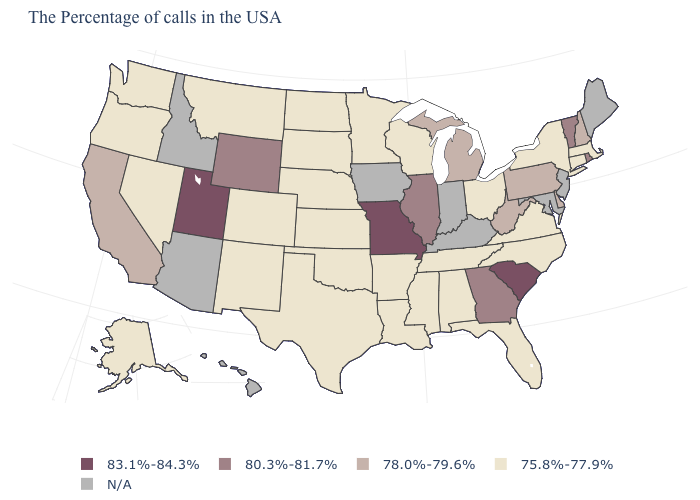Name the states that have a value in the range 78.0%-79.6%?
Write a very short answer. New Hampshire, Delaware, Pennsylvania, West Virginia, Michigan, California. What is the value of West Virginia?
Concise answer only. 78.0%-79.6%. What is the value of Vermont?
Keep it brief. 80.3%-81.7%. What is the lowest value in the USA?
Answer briefly. 75.8%-77.9%. What is the value of Missouri?
Give a very brief answer. 83.1%-84.3%. What is the value of Georgia?
Quick response, please. 80.3%-81.7%. What is the value of Florida?
Keep it brief. 75.8%-77.9%. Does Missouri have the highest value in the USA?
Be succinct. Yes. What is the highest value in the USA?
Be succinct. 83.1%-84.3%. Does Pennsylvania have the highest value in the USA?
Be succinct. No. Among the states that border New Mexico , does Utah have the highest value?
Answer briefly. Yes. Among the states that border Virginia , does North Carolina have the highest value?
Keep it brief. No. Name the states that have a value in the range 80.3%-81.7%?
Keep it brief. Rhode Island, Vermont, Georgia, Illinois, Wyoming. 